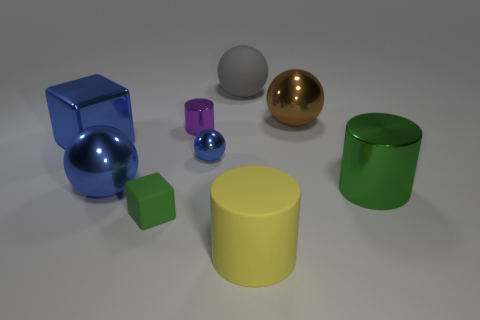How many blue balls must be subtracted to get 1 blue balls? 1 Subtract all green blocks. How many blue balls are left? 2 Subtract 2 spheres. How many spheres are left? 2 Subtract all small blue metal balls. How many balls are left? 3 Subtract all brown balls. How many balls are left? 3 Add 1 large matte blocks. How many objects exist? 10 Subtract all cyan balls. Subtract all purple cylinders. How many balls are left? 4 Subtract all spheres. How many objects are left? 5 Add 1 tiny brown cylinders. How many tiny brown cylinders exist? 1 Subtract 1 gray balls. How many objects are left? 8 